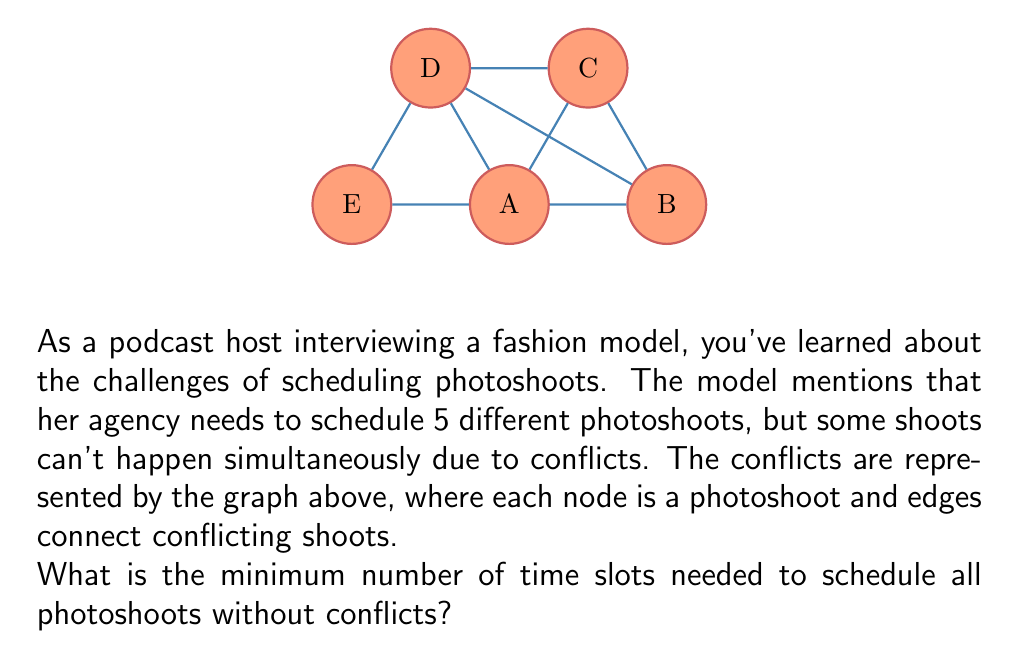Could you help me with this problem? To solve this problem, we can use graph coloring techniques. Each color represents a time slot, and we need to find the chromatic number of the graph, which is the minimum number of colors needed to color all nodes such that no adjacent nodes have the same color.

Step 1: Analyze the graph structure
- The graph forms a wheel with 5 nodes.
- Node C is connected to all other nodes.
- Nodes A, B, D, and E form a cycle.

Step 2: Apply the graph coloring algorithm
1) Start with node C. Assign it color 1.
2) All other nodes must have different colors from C.
3) For the remaining cycle (A-B-D-E):
   - Assign color 2 to A.
   - Assign color 3 to B.
   - Assign color 2 to D (it can share a color with A).
   - Assign color 3 to E (it can share a color with B).

Step 3: Count the number of colors used
We used 3 colors in total: 1 for C, and 2 and 3 alternating for the cycle.

Step 4: Verify the solution
- No adjacent nodes have the same color.
- It's impossible to use fewer than 3 colors because C needs a unique color, and the cycle requires at least 2 colors.

Therefore, the minimum number of time slots (colors) needed is 3.
Answer: 3 